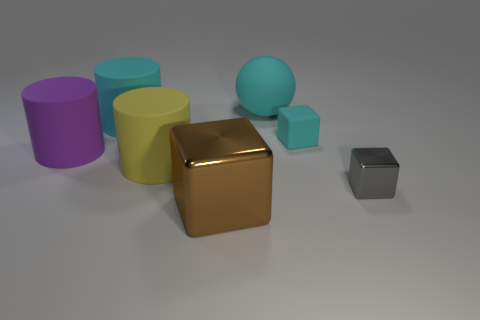What could be the possible context or setting for these objects? The arrangement of these objects seems to be intentionally placed for either a study of color and geometry, or as a part of a visual art piece. The plain, off-white background suggests a controlled setting, indicative of a photography studio setup or a 3D modeling render designed to focus attention solely on the objects themselves.  Do these objects tell a story or convey a message? While inanimate objects don't inherently tell a story, the viewer can interpret the arrangement and colors as an expression of creativity or as elements of a broader narrative about diversity and unity in form. Each object is distinct yet coexists harmoniously in the same space, which can be metaphorical for various concepts, depending on the viewer's perspective. 